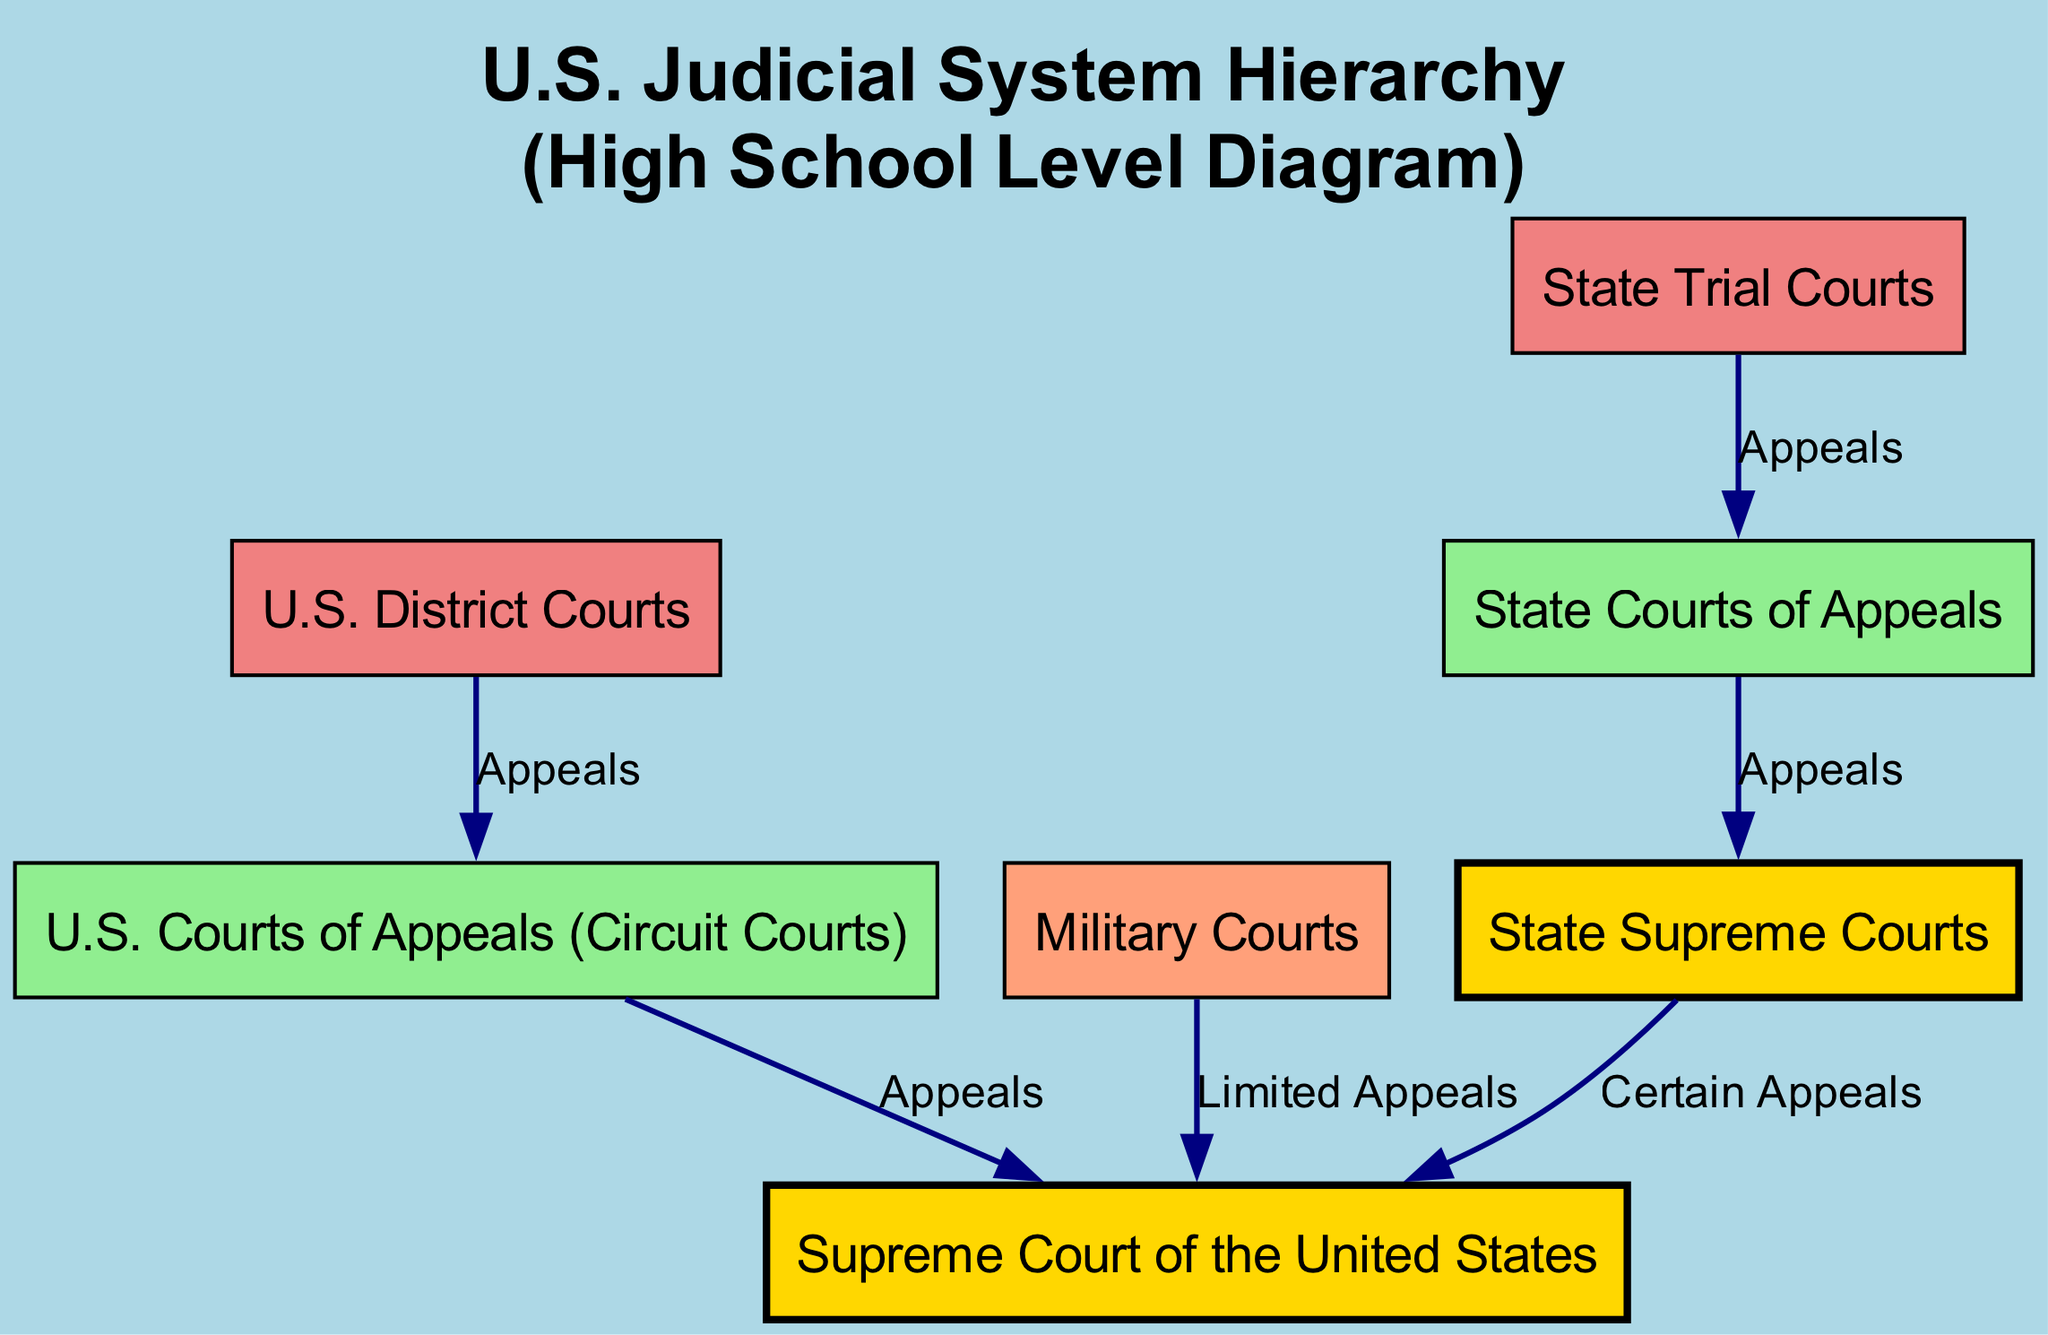What is the highest court in the U.S. judicial system? The highest court in the U.S. judicial system is the Supreme Court of the United States, which is represented at the top of the flowchart.
Answer: Supreme Court of the United States How many different types of courts are listed in the diagram? The diagram outlines seven different types of courts, each represented by a distinct node. These include the Supreme Court, Circuit Courts, District Courts, Military Courts, State Supreme Courts, State Courts of Appeals, and State Trial Courts.
Answer: 7 Which courts can appeal to the Supreme Court? The courts that can appeal to the Supreme Court include U.S. Courts of Appeals (Circuit Courts), Military Courts, and State Supreme Courts. These relationships are shown by directed edges leading to the Supreme Court node.
Answer: U.S. Courts of Appeals, Military Courts, State Supreme Courts From which court do most appeals originate in the federal system? Most appeals in the federal system originate from the U.S. District Courts, which are shown as the base court before appealing to the U.S. Courts of Appeals.
Answer: U.S. District Courts What color represents the U.S. District Courts in the diagram? The U.S. District Courts are represented in light coral color in the diagram, which distinguishes them visually from other court types.
Answer: Light coral What is the relationship between State Trial Courts and State Supreme Courts? The relationship shows that appeals go from State Trial Courts to State Courts of Appeals and then to State Supreme Courts. This indicates a multi-step appeal process within the state court system.
Answer: Appeals Which type of court is shown as having limited appeal to the Supreme Court? Military Courts are indicated as having a limited appeal to the Supreme Court of the United States, as shown by the directed edge labeled "Limited Appeals."
Answer: Military Courts How many edges are there in total within the diagram? The diagram contains six edges, which illustrate the appeal relationships between the various courts.
Answer: 6 